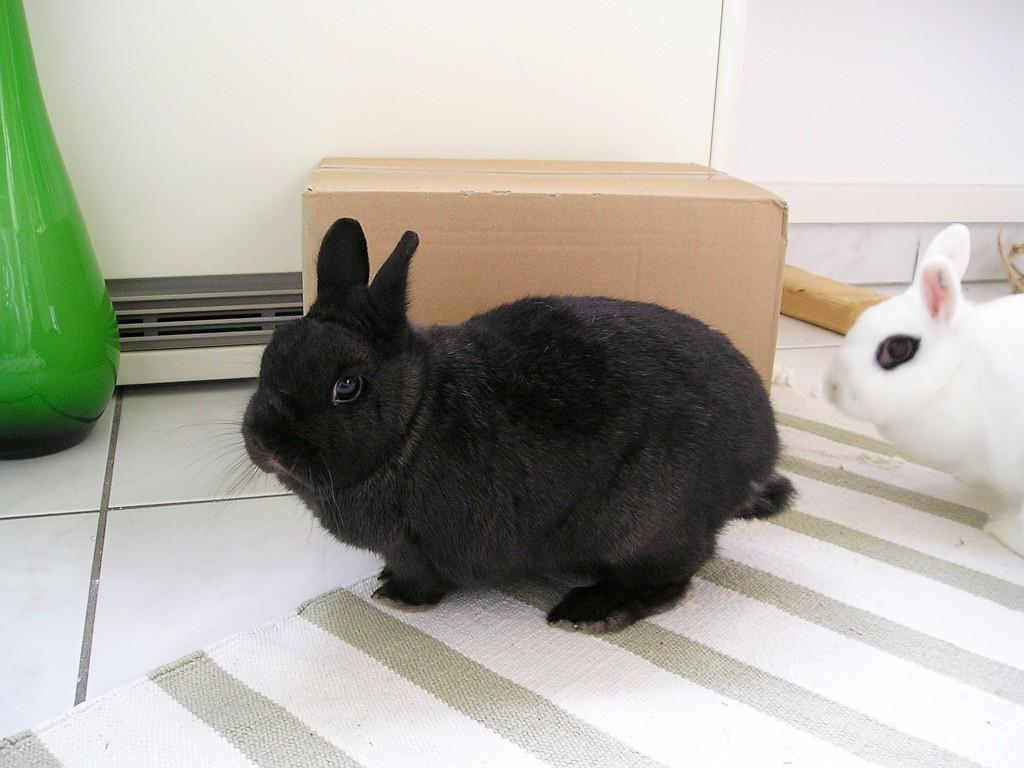How many rabbits are in the image? There are two rabbits in the image. What surface are the rabbits standing on? The rabbits are standing on a mat. Where is the mat located? The mat is on the floor. What is located on the left side of the image? There is a bottle on the left side of the image. What is beside the bottle? There is a cardboard box beside the bottle. What can be seen in the background of the image? There is a wall in the background of the image. What sound can be heard coming from the sticks in the image? There are no sticks present in the image, so no sound can be heard from them. 